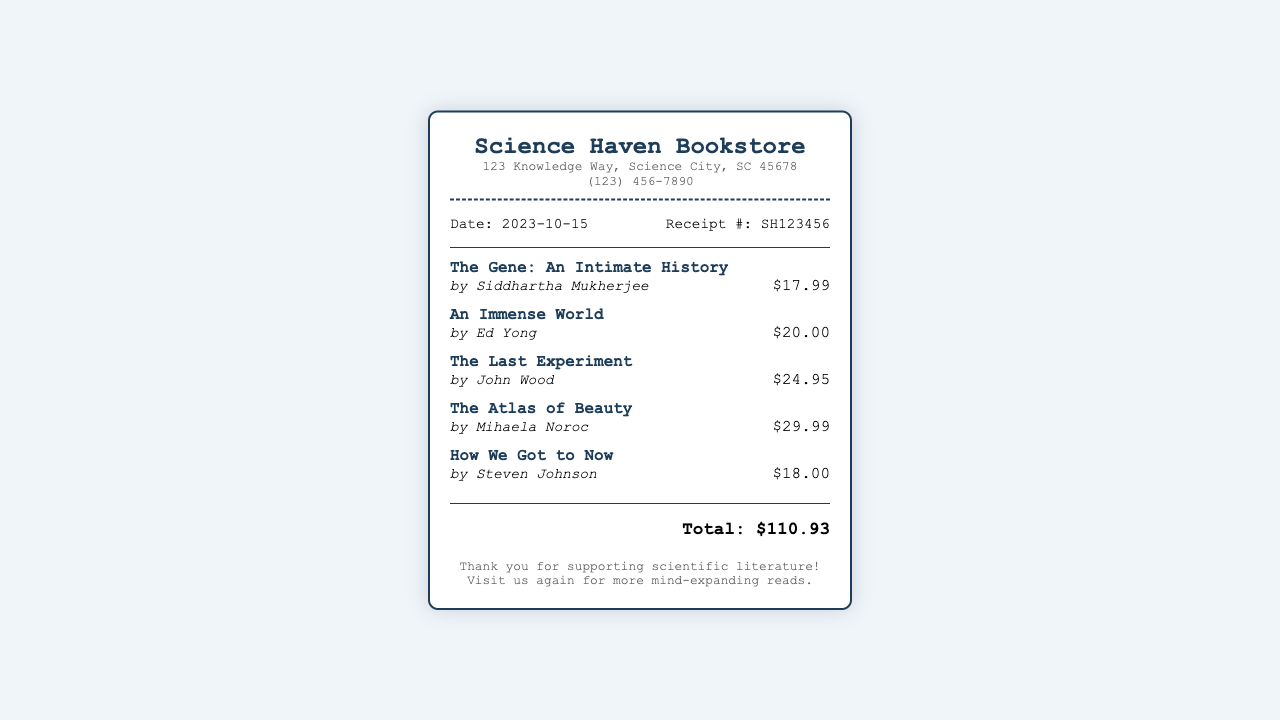What is the store name? The store name is prominently displayed at the top of the receipt.
Answer: Science Haven Bookstore What is the date of the purchase? The date is listed in the receipt details section.
Answer: 2023-10-15 Who is the author of "An Immense World"? The author for specific books is stated below each title on the receipt.
Answer: Ed Yong What is the price of "The Atlas of Beauty"? The price is shown beside the item title in the item section.
Answer: $29.99 What is the total amount spent? The total is summarized at the bottom of the receipt.
Answer: $110.93 What is the receipt number? The receipt number is found in the receipt details section.
Answer: SH123456 How many books were purchased? The number of items is indicated by counting the individual book entries in the items section.
Answer: 5 Which book has the highest price? The book with the highest price can be found by comparing the prices listed.
Answer: The Atlas of Beauty What message is given in the footer? The footer contains a closing note to the customer.
Answer: Thank you for supporting scientific literature! 